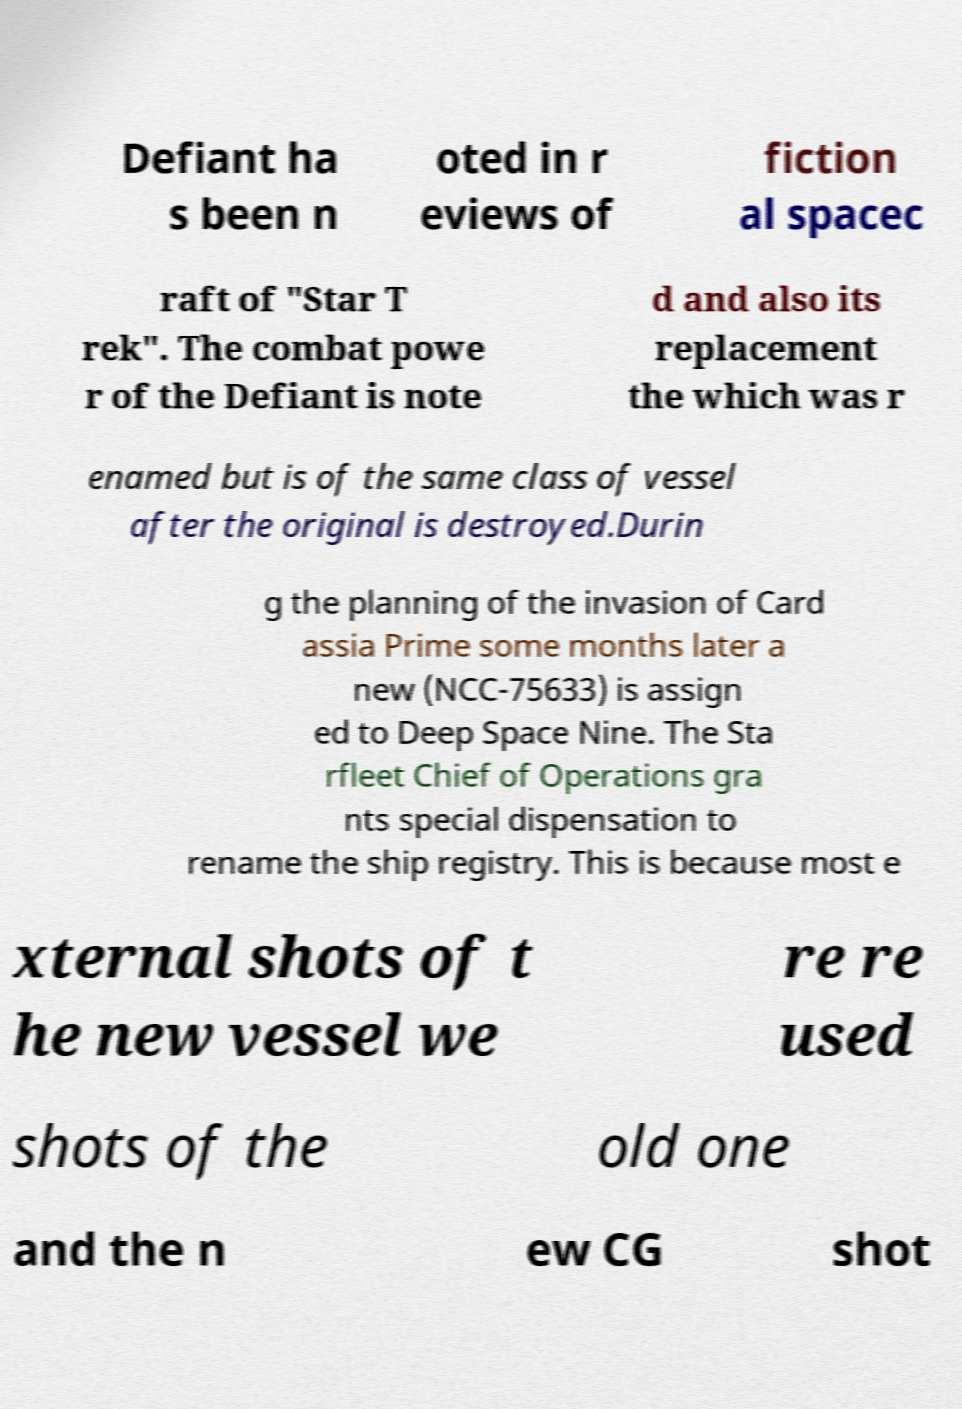There's text embedded in this image that I need extracted. Can you transcribe it verbatim? Defiant ha s been n oted in r eviews of fiction al spacec raft of "Star T rek". The combat powe r of the Defiant is note d and also its replacement the which was r enamed but is of the same class of vessel after the original is destroyed.Durin g the planning of the invasion of Card assia Prime some months later a new (NCC-75633) is assign ed to Deep Space Nine. The Sta rfleet Chief of Operations gra nts special dispensation to rename the ship registry. This is because most e xternal shots of t he new vessel we re re used shots of the old one and the n ew CG shot 